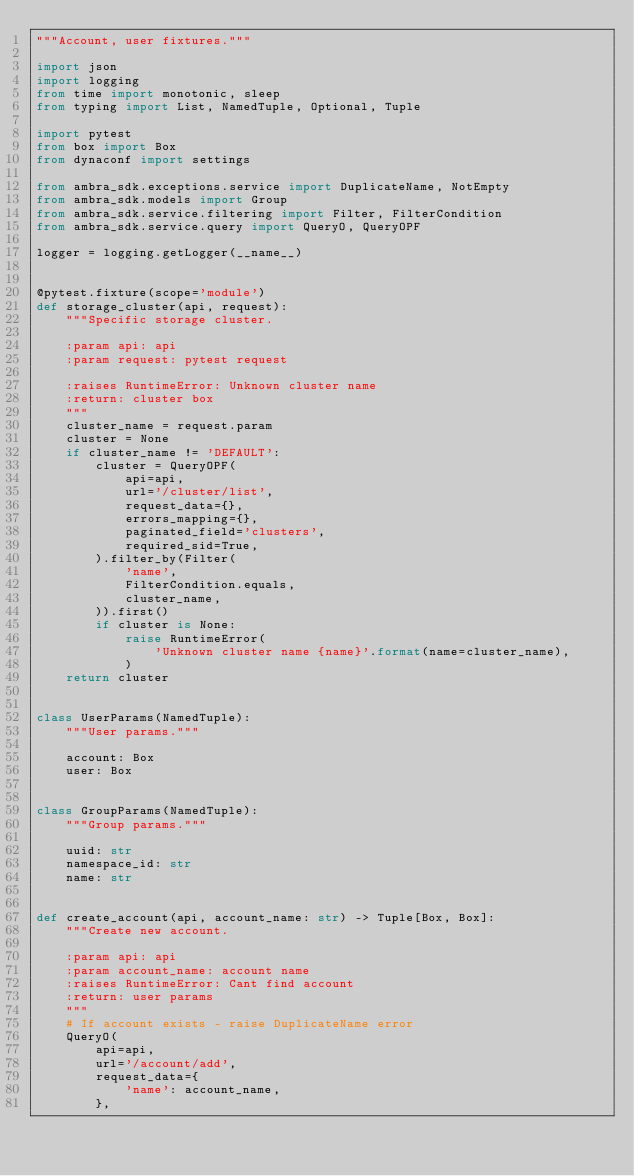Convert code to text. <code><loc_0><loc_0><loc_500><loc_500><_Python_>"""Account, user fixtures."""

import json
import logging
from time import monotonic, sleep
from typing import List, NamedTuple, Optional, Tuple

import pytest
from box import Box
from dynaconf import settings

from ambra_sdk.exceptions.service import DuplicateName, NotEmpty
from ambra_sdk.models import Group
from ambra_sdk.service.filtering import Filter, FilterCondition
from ambra_sdk.service.query import QueryO, QueryOPF

logger = logging.getLogger(__name__)


@pytest.fixture(scope='module')
def storage_cluster(api, request):
    """Specific storage cluster.

    :param api: api
    :param request: pytest request

    :raises RuntimeError: Unknown cluster name
    :return: cluster box
    """
    cluster_name = request.param
    cluster = None
    if cluster_name != 'DEFAULT':
        cluster = QueryOPF(
            api=api,
            url='/cluster/list',
            request_data={},
            errors_mapping={},
            paginated_field='clusters',
            required_sid=True,
        ).filter_by(Filter(
            'name',
            FilterCondition.equals,
            cluster_name,
        )).first()
        if cluster is None:
            raise RuntimeError(
                'Unknown cluster name {name}'.format(name=cluster_name),
            )
    return cluster


class UserParams(NamedTuple):
    """User params."""

    account: Box
    user: Box


class GroupParams(NamedTuple):
    """Group params."""

    uuid: str
    namespace_id: str
    name: str


def create_account(api, account_name: str) -> Tuple[Box, Box]:
    """Create new account.

    :param api: api
    :param account_name: account name
    :raises RuntimeError: Cant find account
    :return: user params
    """
    # If account exists - raise DuplicateName error
    QueryO(
        api=api,
        url='/account/add',
        request_data={
            'name': account_name,
        },</code> 